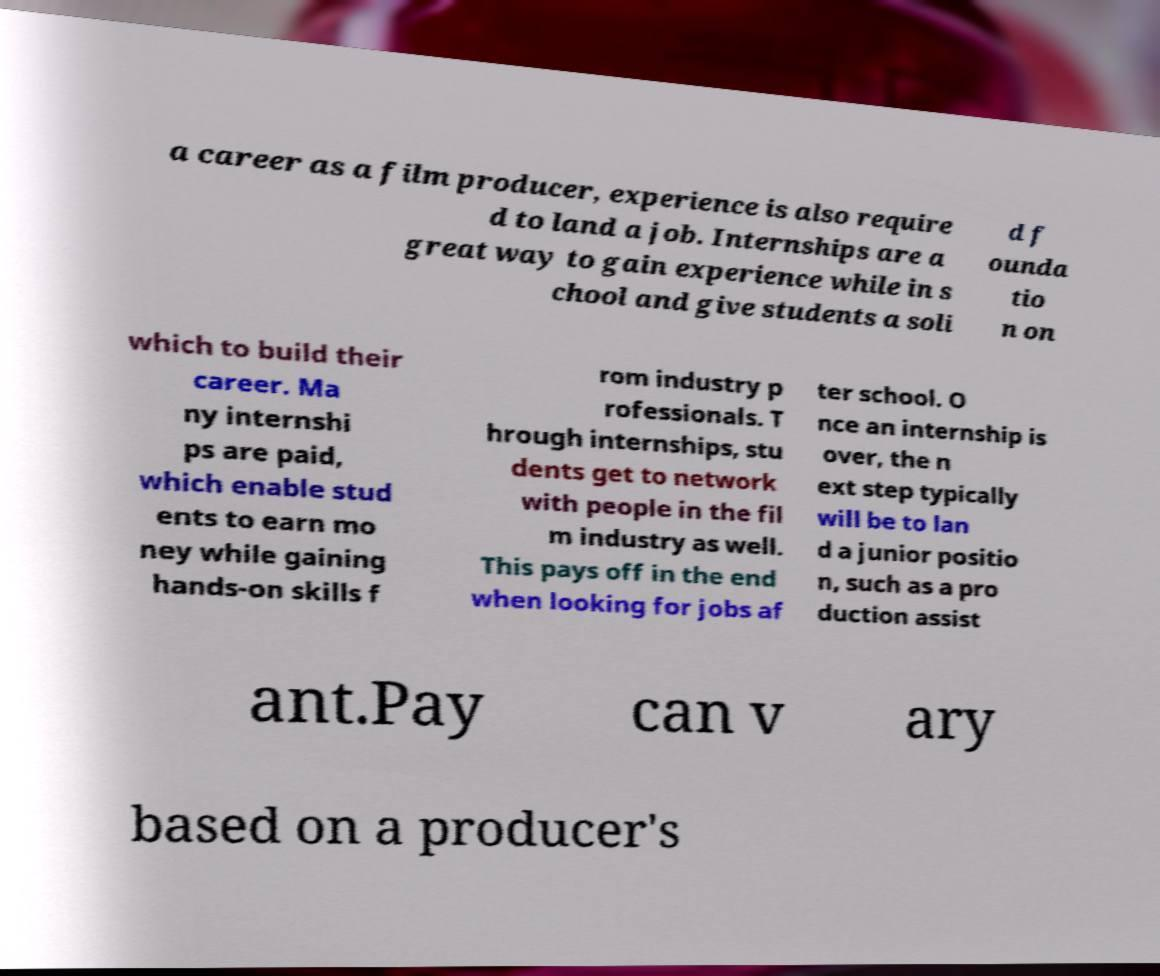Can you accurately transcribe the text from the provided image for me? a career as a film producer, experience is also require d to land a job. Internships are a great way to gain experience while in s chool and give students a soli d f ounda tio n on which to build their career. Ma ny internshi ps are paid, which enable stud ents to earn mo ney while gaining hands-on skills f rom industry p rofessionals. T hrough internships, stu dents get to network with people in the fil m industry as well. This pays off in the end when looking for jobs af ter school. O nce an internship is over, the n ext step typically will be to lan d a junior positio n, such as a pro duction assist ant.Pay can v ary based on a producer's 